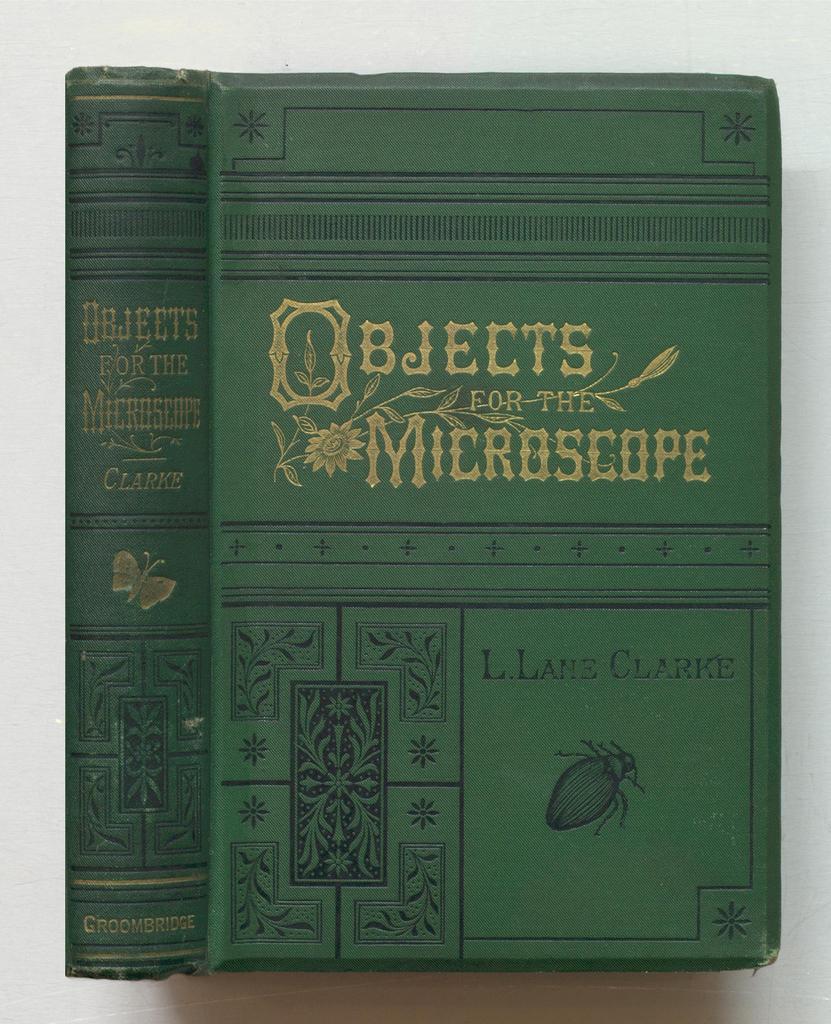What is the title of the green book?
Your response must be concise. Objects for the microscope. Who is the author?
Offer a terse response. L. lane clarke. 